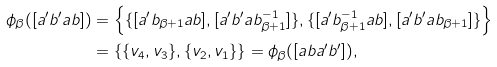<formula> <loc_0><loc_0><loc_500><loc_500>\phi _ { \beta } ( [ a ^ { \prime } b ^ { \prime } a b ] ) & = \left \{ \{ [ a ^ { \prime } b _ { \beta + 1 } a b ] , [ a ^ { \prime } b ^ { \prime } a b _ { \beta + 1 } ^ { - 1 } ] \} , \{ [ a ^ { \prime } b _ { \beta + 1 } ^ { - 1 } a b ] , [ a ^ { \prime } b ^ { \prime } a b _ { \beta + 1 } ] \} \right \} \\ & = \left \{ \{ v _ { 4 } , v _ { 3 } \} , \{ v _ { 2 } , v _ { 1 } \} \right \} = \phi _ { \beta } ( [ a b a ^ { \prime } b ^ { \prime } ] ) ,</formula> 